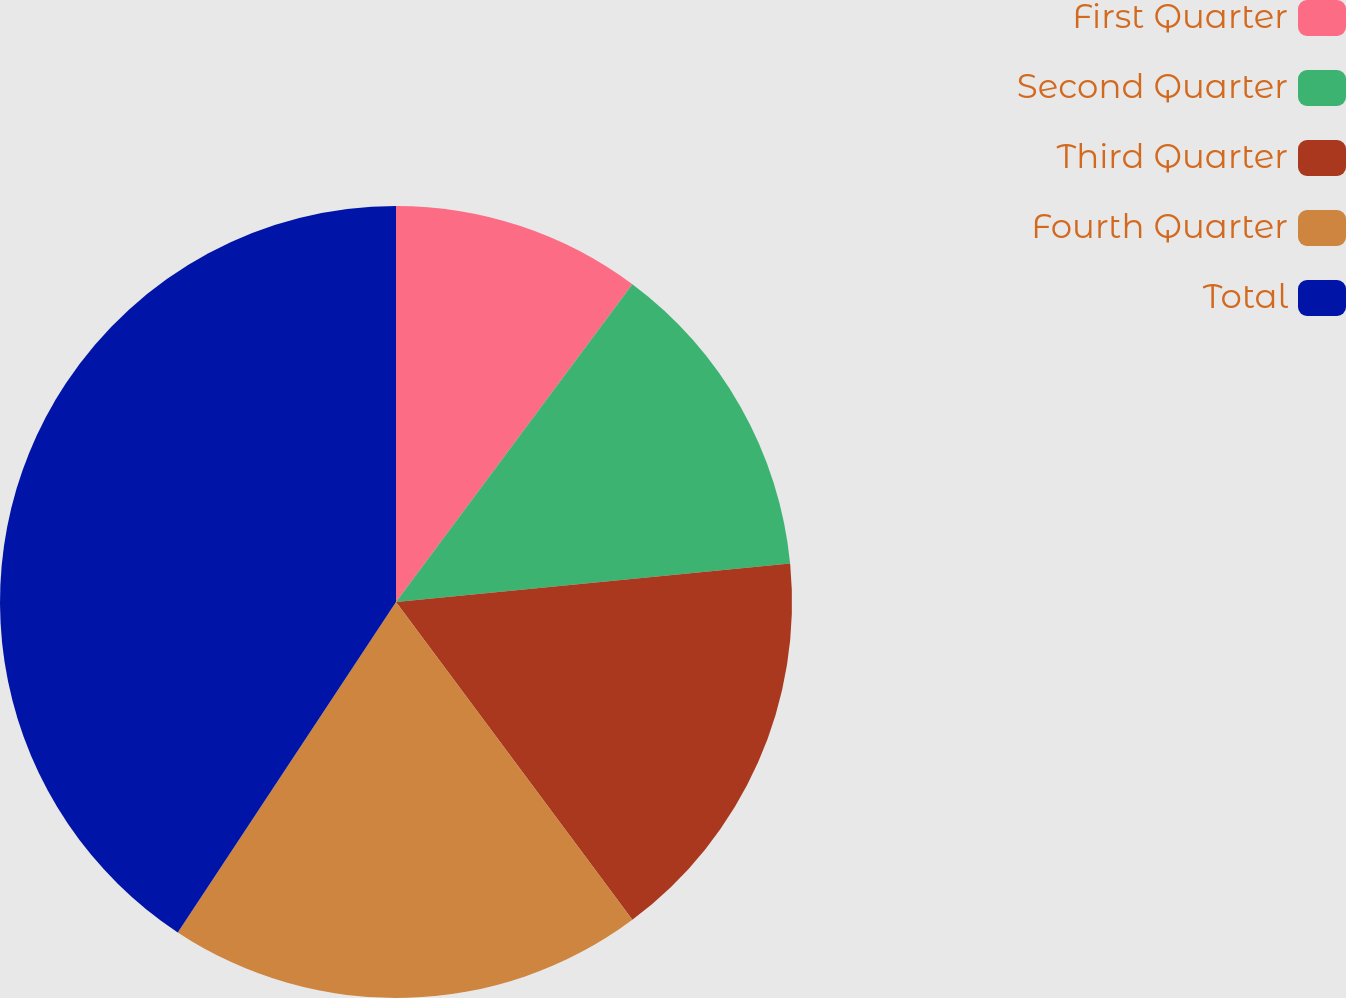Convert chart to OTSL. <chart><loc_0><loc_0><loc_500><loc_500><pie_chart><fcel>First Quarter<fcel>Second Quarter<fcel>Third Quarter<fcel>Fourth Quarter<fcel>Total<nl><fcel>10.18%<fcel>13.27%<fcel>16.37%<fcel>19.47%<fcel>40.71%<nl></chart> 